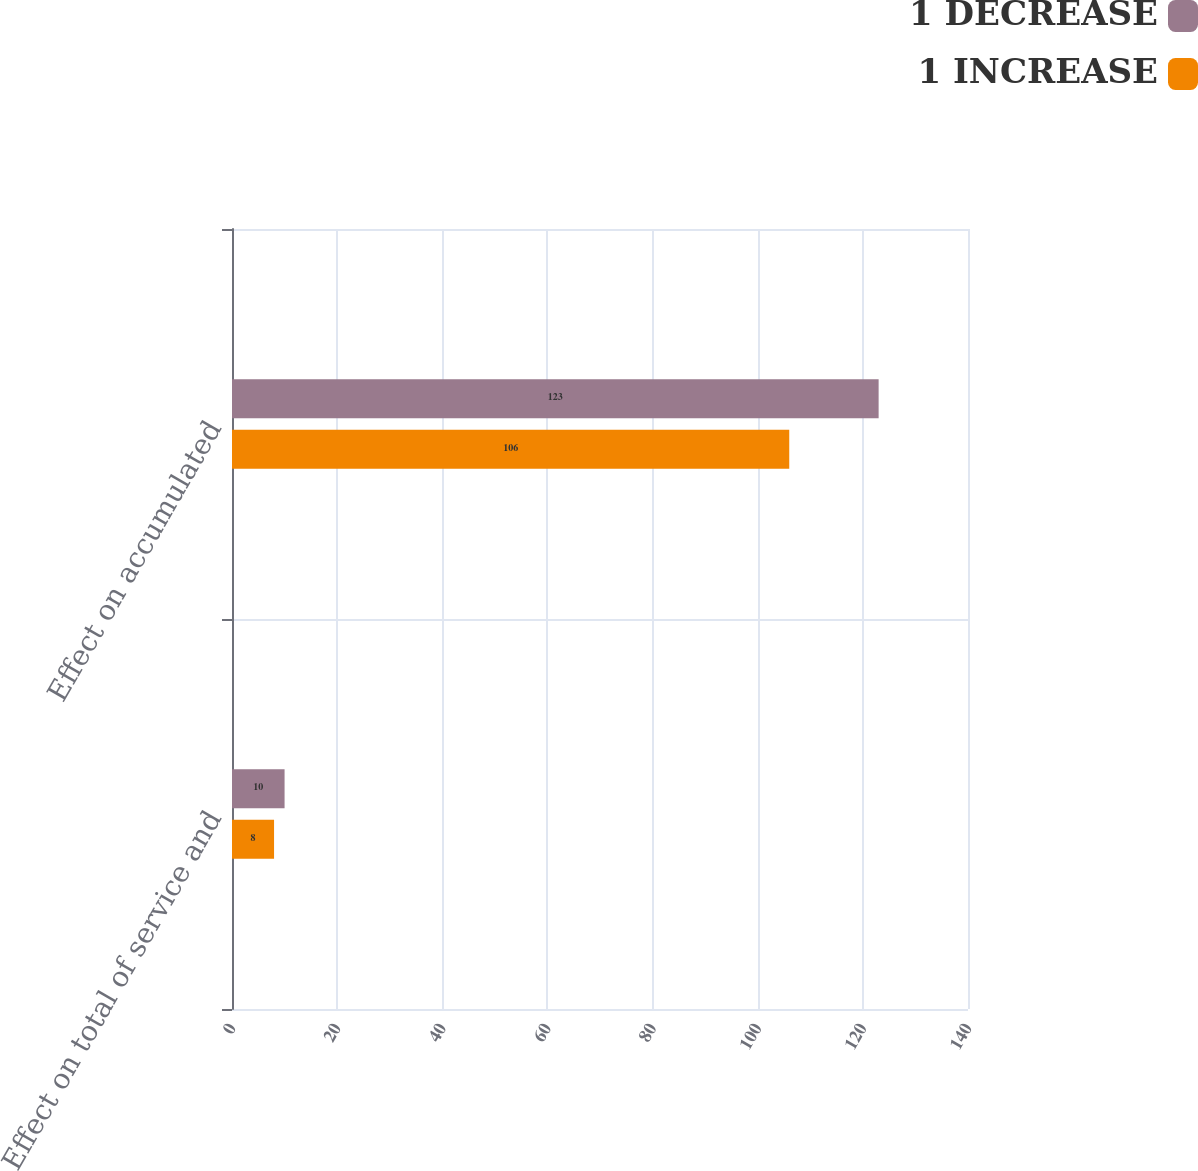Convert chart. <chart><loc_0><loc_0><loc_500><loc_500><stacked_bar_chart><ecel><fcel>Effect on total of service and<fcel>Effect on accumulated<nl><fcel>1 DECREASE<fcel>10<fcel>123<nl><fcel>1 INCREASE<fcel>8<fcel>106<nl></chart> 